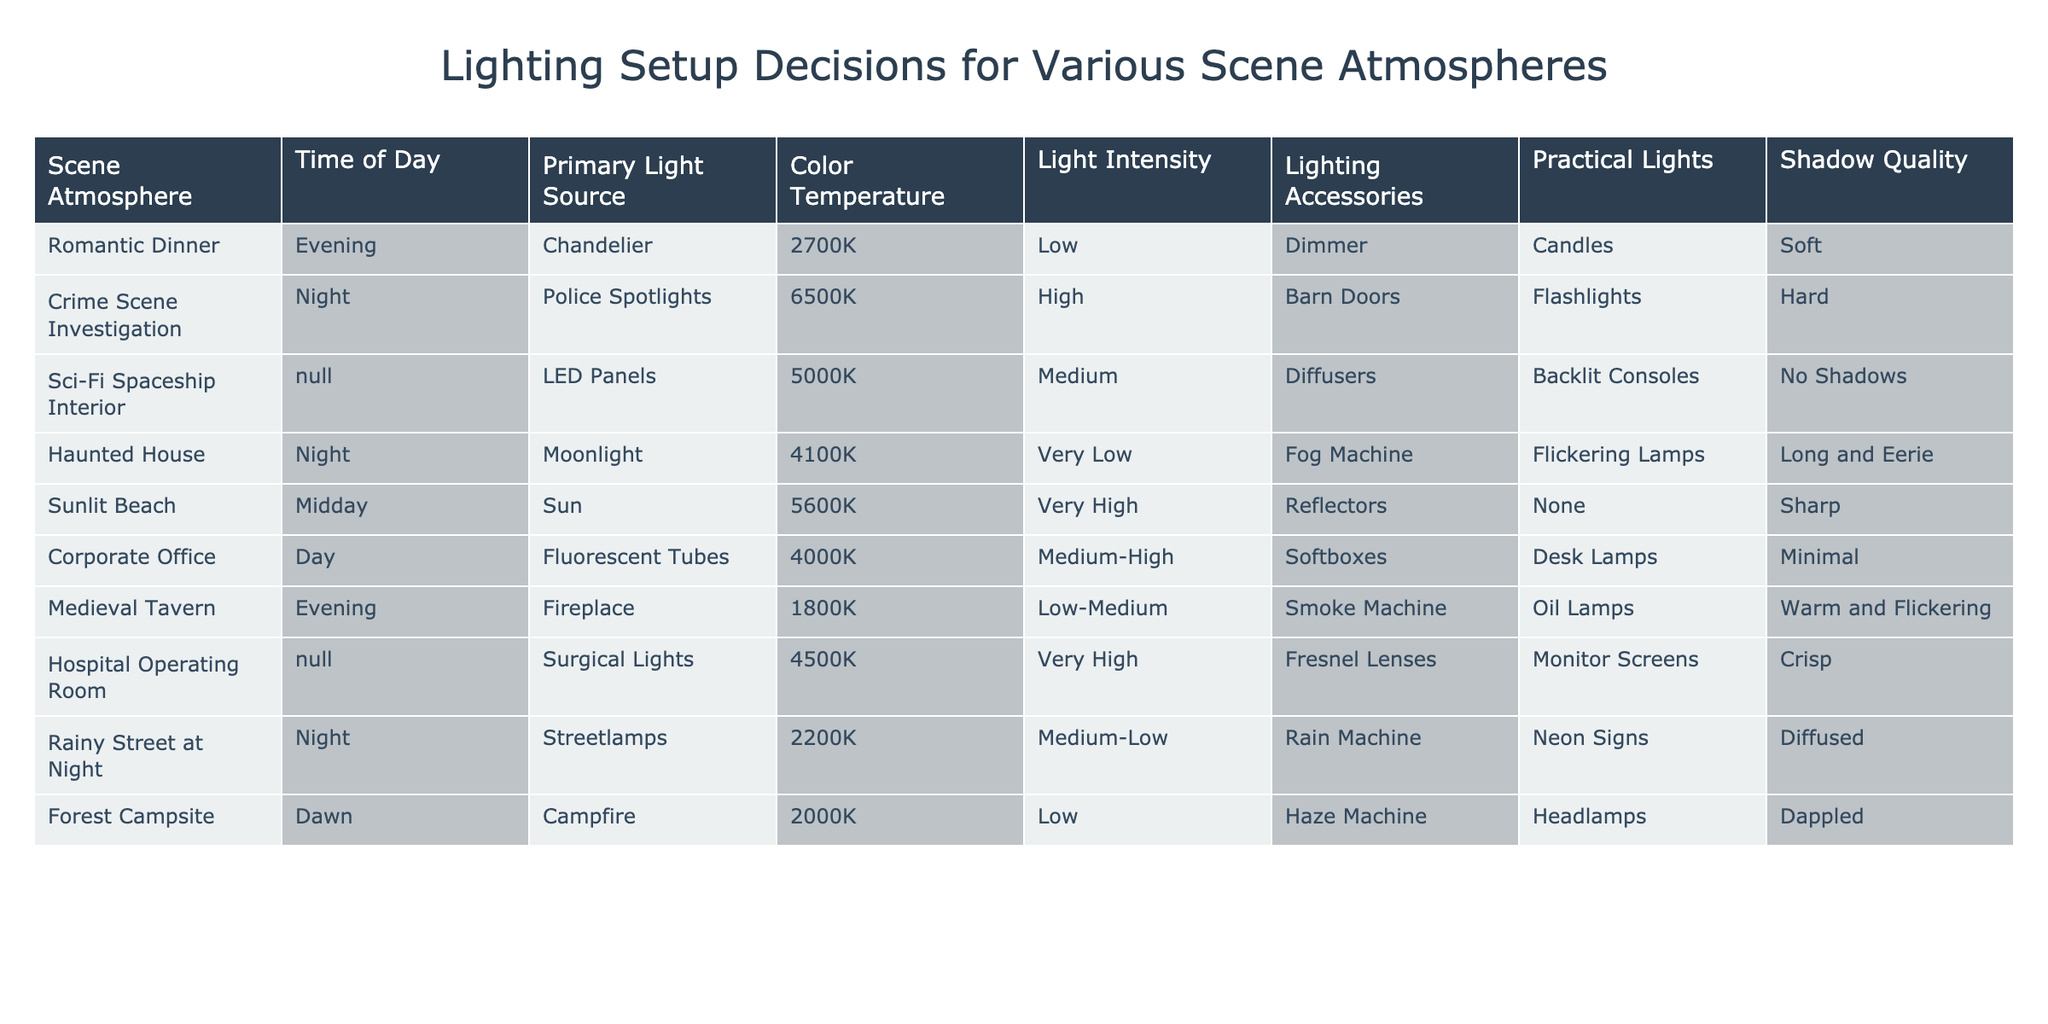What is the primary light source for a romantic dinner scene? The table shows that the primary light source for a romantic dinner is a chandelier. This information can be found directly in the row corresponding to the romantic dinner scene.
Answer: Chandelier What is the color temperature of lighting for a crime scene investigation? From the table, the color temperature for a crime scene investigation is recorded as 6500K. This value can be directly retrieved from the relevant row in the table.
Answer: 6500K How many scenes use practical lights? By inspecting the table, practical lights are present in the rows for Romantic Dinner (Candles), Haunted House (Flickering Lamps), Medieval Tavern (Oil Lamps), and Rainy Street at Night (Neon Signs). A total of four scenes employ practical lights.
Answer: 4 What is the average light intensity of all scenes? The light intensity values are Low (1), Very Low (0.5), Medium (2), High (3), and Very High (4). The light intensity ratings convert to numerical values (1, 0.5, 2, 3, and 4) and we sum them: 1 + 0.5 + 2 + 3 + 4 (for Hospital Operating Room) + 2 (for Streetlamps) + 1 (for Campfire) = 13. The average is 13 divided by the number of scenes (10): 13/10 = 1.3.
Answer: 1.3 Is there a scene with a shadow quality described as sharp? The table indicates that the Sunlit Beach scene features shadow quality described as sharp. Therefore, this statement is true.
Answer: Yes Which scene atmosphere features a primary light source with a color temperature below 3000K? According to the table, the scenes with primary light sources below 3000K are the Romantic Dinner (chandelier) with 2700K and Medieval Tavern (fireplace) with 1800K. Hence, the answer involves indicating those scenes.
Answer: Romantic Dinner, Medieval Tavern What is the relationship between time of day and shadow quality based on the table? Analyzing the table shows that during Evening (Romantic Dinner, Medieval Tavern), both exhibit soft or warm and flickering shadows. At Night (Crime Scene Investigation, Rainy Street at Night), shadows range from hard to diffused. During Daylight (Corporate Office), shadow quality is minimal while at Midday (Sunlit Beach), shadows are sharp. The relationship implies that night scenes often have harsher shadows whereas daytime scenes yield softer qualities or minimal shadows.
Answer: Evening = Soft/Warm; Night = Hard/Diffused; Day = Minimal/Sharp How many scenes feature very high light intensity? By checking the table, we find that only the Hospital Operating Room and Crime Scene Investigation have a very high light intensity, thus there are two such scenes.
Answer: 2 What type of lighting accessory is used in a haunted house scene? The table lists the lighting accessory for the Haunted House as a fog machine. This is a straightforward lookup in the table for that scene atmosphere.
Answer: Fog Machine 